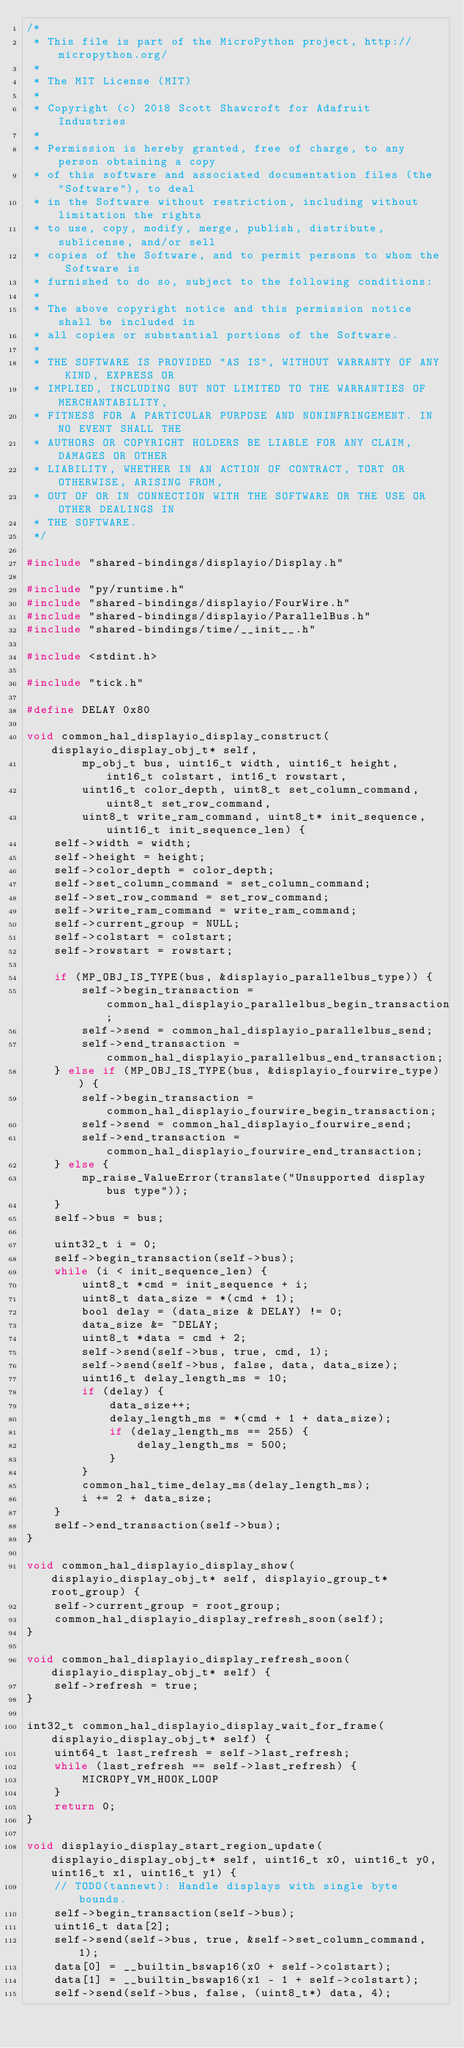<code> <loc_0><loc_0><loc_500><loc_500><_C_>/*
 * This file is part of the MicroPython project, http://micropython.org/
 *
 * The MIT License (MIT)
 *
 * Copyright (c) 2018 Scott Shawcroft for Adafruit Industries
 *
 * Permission is hereby granted, free of charge, to any person obtaining a copy
 * of this software and associated documentation files (the "Software"), to deal
 * in the Software without restriction, including without limitation the rights
 * to use, copy, modify, merge, publish, distribute, sublicense, and/or sell
 * copies of the Software, and to permit persons to whom the Software is
 * furnished to do so, subject to the following conditions:
 *
 * The above copyright notice and this permission notice shall be included in
 * all copies or substantial portions of the Software.
 *
 * THE SOFTWARE IS PROVIDED "AS IS", WITHOUT WARRANTY OF ANY KIND, EXPRESS OR
 * IMPLIED, INCLUDING BUT NOT LIMITED TO THE WARRANTIES OF MERCHANTABILITY,
 * FITNESS FOR A PARTICULAR PURPOSE AND NONINFRINGEMENT. IN NO EVENT SHALL THE
 * AUTHORS OR COPYRIGHT HOLDERS BE LIABLE FOR ANY CLAIM, DAMAGES OR OTHER
 * LIABILITY, WHETHER IN AN ACTION OF CONTRACT, TORT OR OTHERWISE, ARISING FROM,
 * OUT OF OR IN CONNECTION WITH THE SOFTWARE OR THE USE OR OTHER DEALINGS IN
 * THE SOFTWARE.
 */

#include "shared-bindings/displayio/Display.h"

#include "py/runtime.h"
#include "shared-bindings/displayio/FourWire.h"
#include "shared-bindings/displayio/ParallelBus.h"
#include "shared-bindings/time/__init__.h"

#include <stdint.h>

#include "tick.h"

#define DELAY 0x80

void common_hal_displayio_display_construct(displayio_display_obj_t* self,
        mp_obj_t bus, uint16_t width, uint16_t height, int16_t colstart, int16_t rowstart,
        uint16_t color_depth, uint8_t set_column_command, uint8_t set_row_command,
        uint8_t write_ram_command, uint8_t* init_sequence, uint16_t init_sequence_len) {
    self->width = width;
    self->height = height;
    self->color_depth = color_depth;
    self->set_column_command = set_column_command;
    self->set_row_command = set_row_command;
    self->write_ram_command = write_ram_command;
    self->current_group = NULL;
    self->colstart = colstart;
    self->rowstart = rowstart;

    if (MP_OBJ_IS_TYPE(bus, &displayio_parallelbus_type)) {
        self->begin_transaction = common_hal_displayio_parallelbus_begin_transaction;
        self->send = common_hal_displayio_parallelbus_send;
        self->end_transaction = common_hal_displayio_parallelbus_end_transaction;
    } else if (MP_OBJ_IS_TYPE(bus, &displayio_fourwire_type)) {
        self->begin_transaction = common_hal_displayio_fourwire_begin_transaction;
        self->send = common_hal_displayio_fourwire_send;
        self->end_transaction = common_hal_displayio_fourwire_end_transaction;
    } else {
        mp_raise_ValueError(translate("Unsupported display bus type"));
    }
    self->bus = bus;

    uint32_t i = 0;
    self->begin_transaction(self->bus);
    while (i < init_sequence_len) {
        uint8_t *cmd = init_sequence + i;
        uint8_t data_size = *(cmd + 1);
        bool delay = (data_size & DELAY) != 0;
        data_size &= ~DELAY;
        uint8_t *data = cmd + 2;
        self->send(self->bus, true, cmd, 1);
        self->send(self->bus, false, data, data_size);
        uint16_t delay_length_ms = 10;
        if (delay) {
            data_size++;
            delay_length_ms = *(cmd + 1 + data_size);
            if (delay_length_ms == 255) {
                delay_length_ms = 500;
            }
        }
        common_hal_time_delay_ms(delay_length_ms);
        i += 2 + data_size;
    }
    self->end_transaction(self->bus);
}

void common_hal_displayio_display_show(displayio_display_obj_t* self, displayio_group_t* root_group) {
    self->current_group = root_group;
    common_hal_displayio_display_refresh_soon(self);
}

void common_hal_displayio_display_refresh_soon(displayio_display_obj_t* self) {
    self->refresh = true;
}

int32_t common_hal_displayio_display_wait_for_frame(displayio_display_obj_t* self) {
    uint64_t last_refresh = self->last_refresh;
    while (last_refresh == self->last_refresh) {
        MICROPY_VM_HOOK_LOOP
    }
    return 0;
}

void displayio_display_start_region_update(displayio_display_obj_t* self, uint16_t x0, uint16_t y0, uint16_t x1, uint16_t y1) {
    // TODO(tannewt): Handle displays with single byte bounds.
    self->begin_transaction(self->bus);
    uint16_t data[2];
    self->send(self->bus, true, &self->set_column_command, 1);
    data[0] = __builtin_bswap16(x0 + self->colstart);
    data[1] = __builtin_bswap16(x1 - 1 + self->colstart);
    self->send(self->bus, false, (uint8_t*) data, 4);</code> 